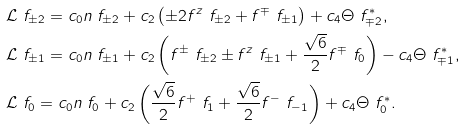<formula> <loc_0><loc_0><loc_500><loc_500>& \mathcal { L } \ f _ { \pm 2 } = c _ { 0 } n \ f _ { \pm 2 } + c _ { 2 } \left ( \pm 2 f ^ { z } \ f _ { \pm 2 } + f ^ { \mp } \ f _ { \pm 1 } \right ) + c _ { 4 } \Theta \ f _ { \mp 2 } ^ { * } , \\ & \mathcal { L } \ f _ { \pm 1 } = c _ { 0 } n \ f _ { \pm 1 } + c _ { 2 } \left ( f ^ { \pm } \ f _ { \pm 2 } \pm f ^ { z } \ f _ { \pm 1 } + \frac { \sqrt { 6 } } { 2 } f ^ { \mp } \ f _ { 0 } \right ) - c _ { 4 } \Theta \ f _ { \mp 1 } ^ { * } , \\ & \mathcal { L } \ f _ { 0 } = c _ { 0 } n \ f _ { 0 } + c _ { 2 } \left ( \frac { \sqrt { 6 } } { 2 } f ^ { + } \ f _ { 1 } + \frac { \sqrt { 6 } } { 2 } f ^ { - } \ f _ { - 1 } \right ) + c _ { 4 } \Theta \ f _ { 0 } ^ { * } .</formula> 